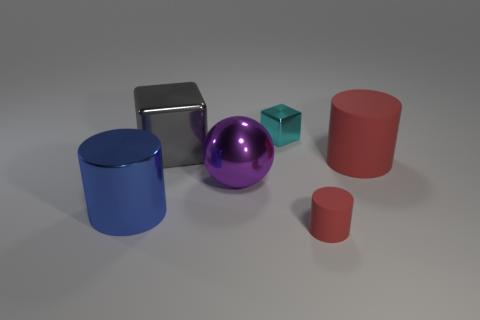Subtract all big cylinders. How many cylinders are left? 1 Add 3 big metal cylinders. How many objects exist? 9 Subtract all blue cylinders. How many cylinders are left? 2 Subtract all green balls. How many red cylinders are left? 2 Subtract all blocks. How many objects are left? 4 Subtract 1 cylinders. How many cylinders are left? 2 Subtract all blue blocks. Subtract all yellow cylinders. How many blocks are left? 2 Subtract all metal things. Subtract all large metal cubes. How many objects are left? 1 Add 2 big purple metallic things. How many big purple metallic things are left? 3 Add 1 metallic cylinders. How many metallic cylinders exist? 2 